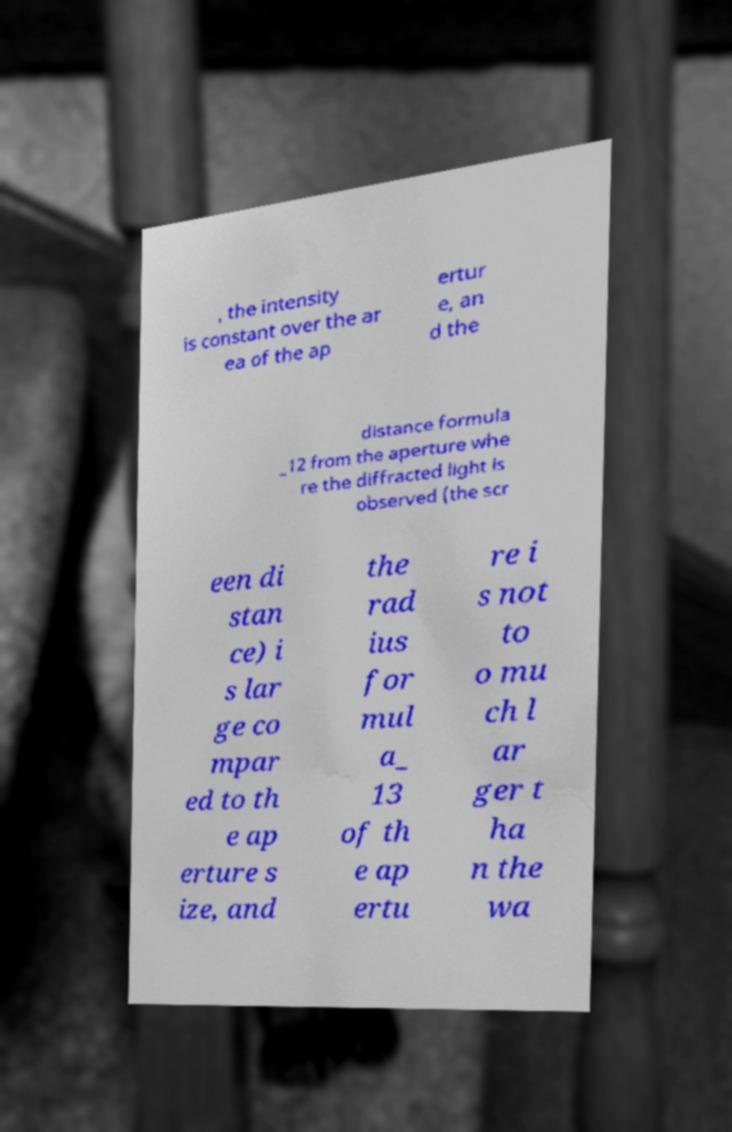Can you accurately transcribe the text from the provided image for me? , the intensity is constant over the ar ea of the ap ertur e, an d the distance formula _12 from the aperture whe re the diffracted light is observed (the scr een di stan ce) i s lar ge co mpar ed to th e ap erture s ize, and the rad ius for mul a_ 13 of th e ap ertu re i s not to o mu ch l ar ger t ha n the wa 